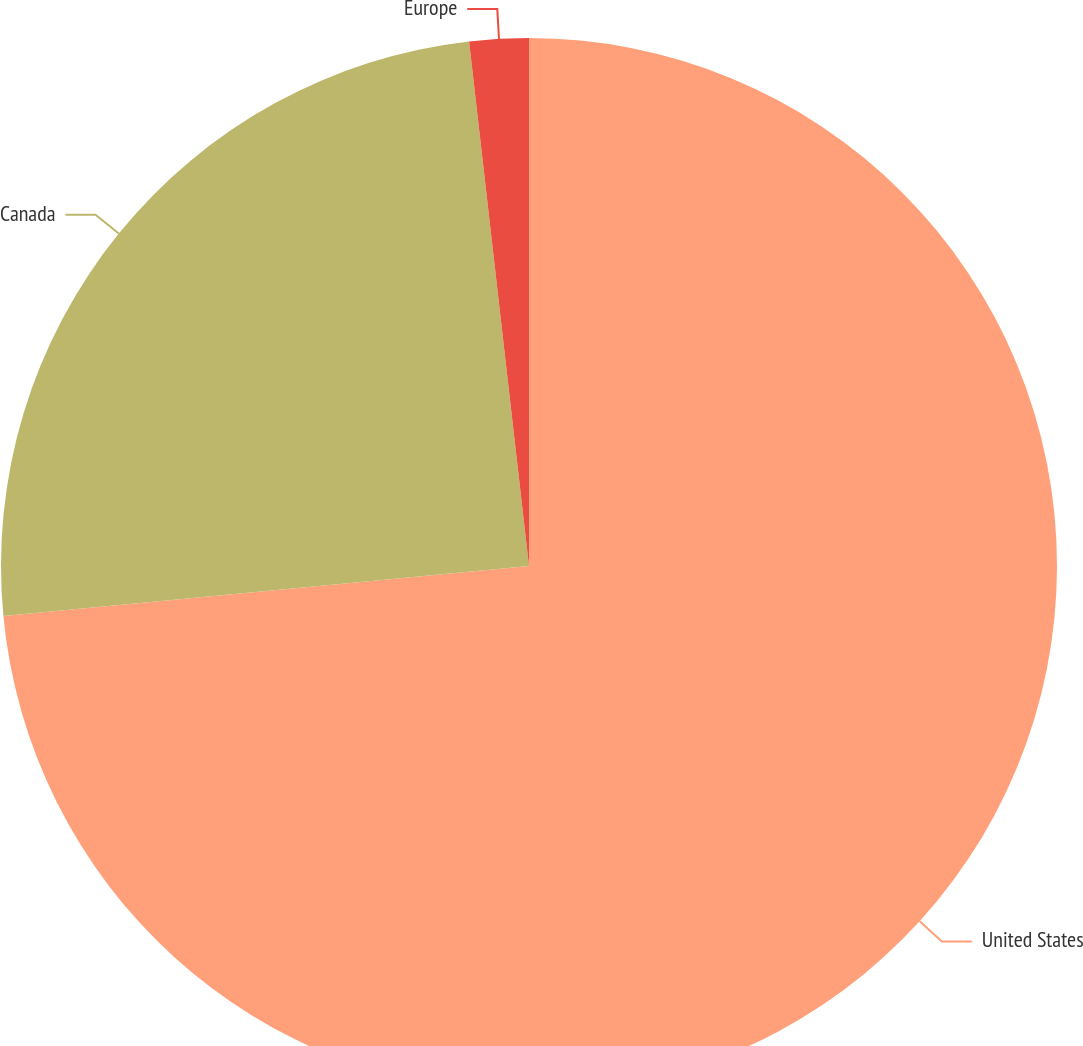Convert chart to OTSL. <chart><loc_0><loc_0><loc_500><loc_500><pie_chart><fcel>United States<fcel>Canada<fcel>Europe<nl><fcel>73.48%<fcel>24.7%<fcel>1.81%<nl></chart> 